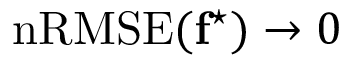Convert formula to latex. <formula><loc_0><loc_0><loc_500><loc_500>n R M S E ( f ^ { ^ { * } } ) \rightarrow 0</formula> 